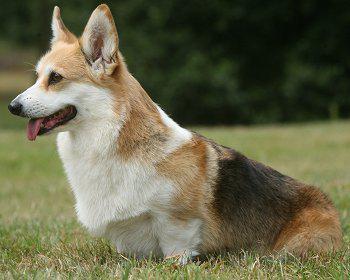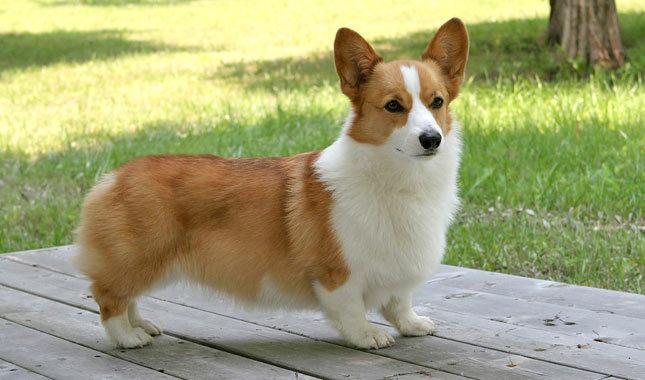The first image is the image on the left, the second image is the image on the right. Considering the images on both sides, is "There is exactly two dogs in the right image." valid? Answer yes or no. No. The first image is the image on the left, the second image is the image on the right. Assess this claim about the two images: "An image shows a forward-facing dog with its mouth closed.". Correct or not? Answer yes or no. Yes. 